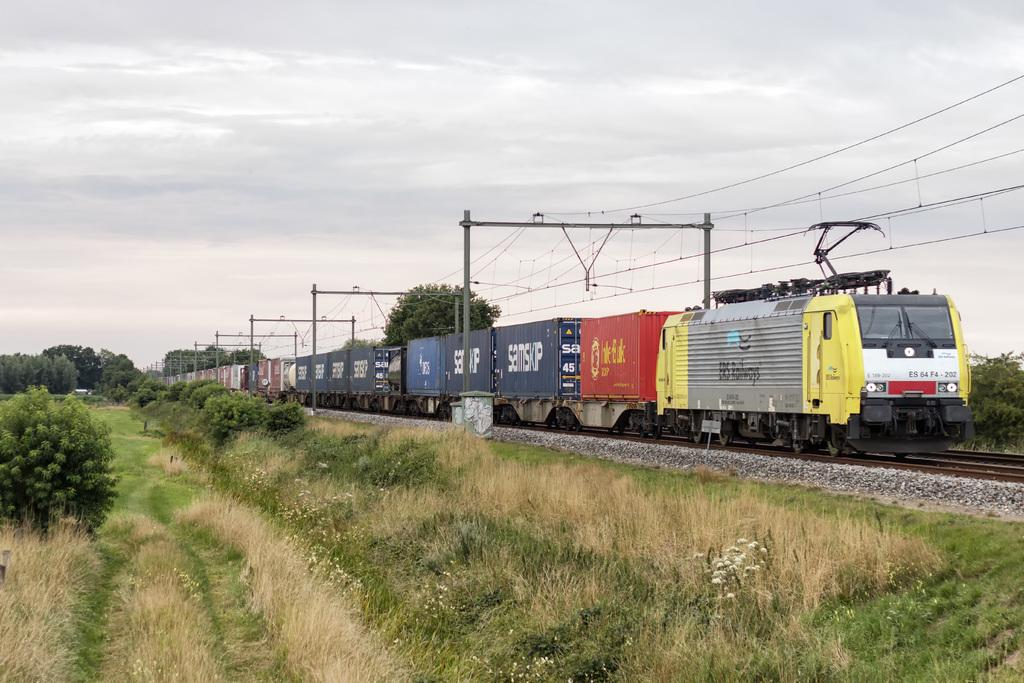<image>
Provide a brief description of the given image. A train is on the tracks with the number 202 on the front corner. 